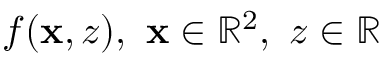Convert formula to latex. <formula><loc_0><loc_0><loc_500><loc_500>f ( x , z ) , x \in \mathbb { R } ^ { 2 } , z \in \mathbb { R }</formula> 